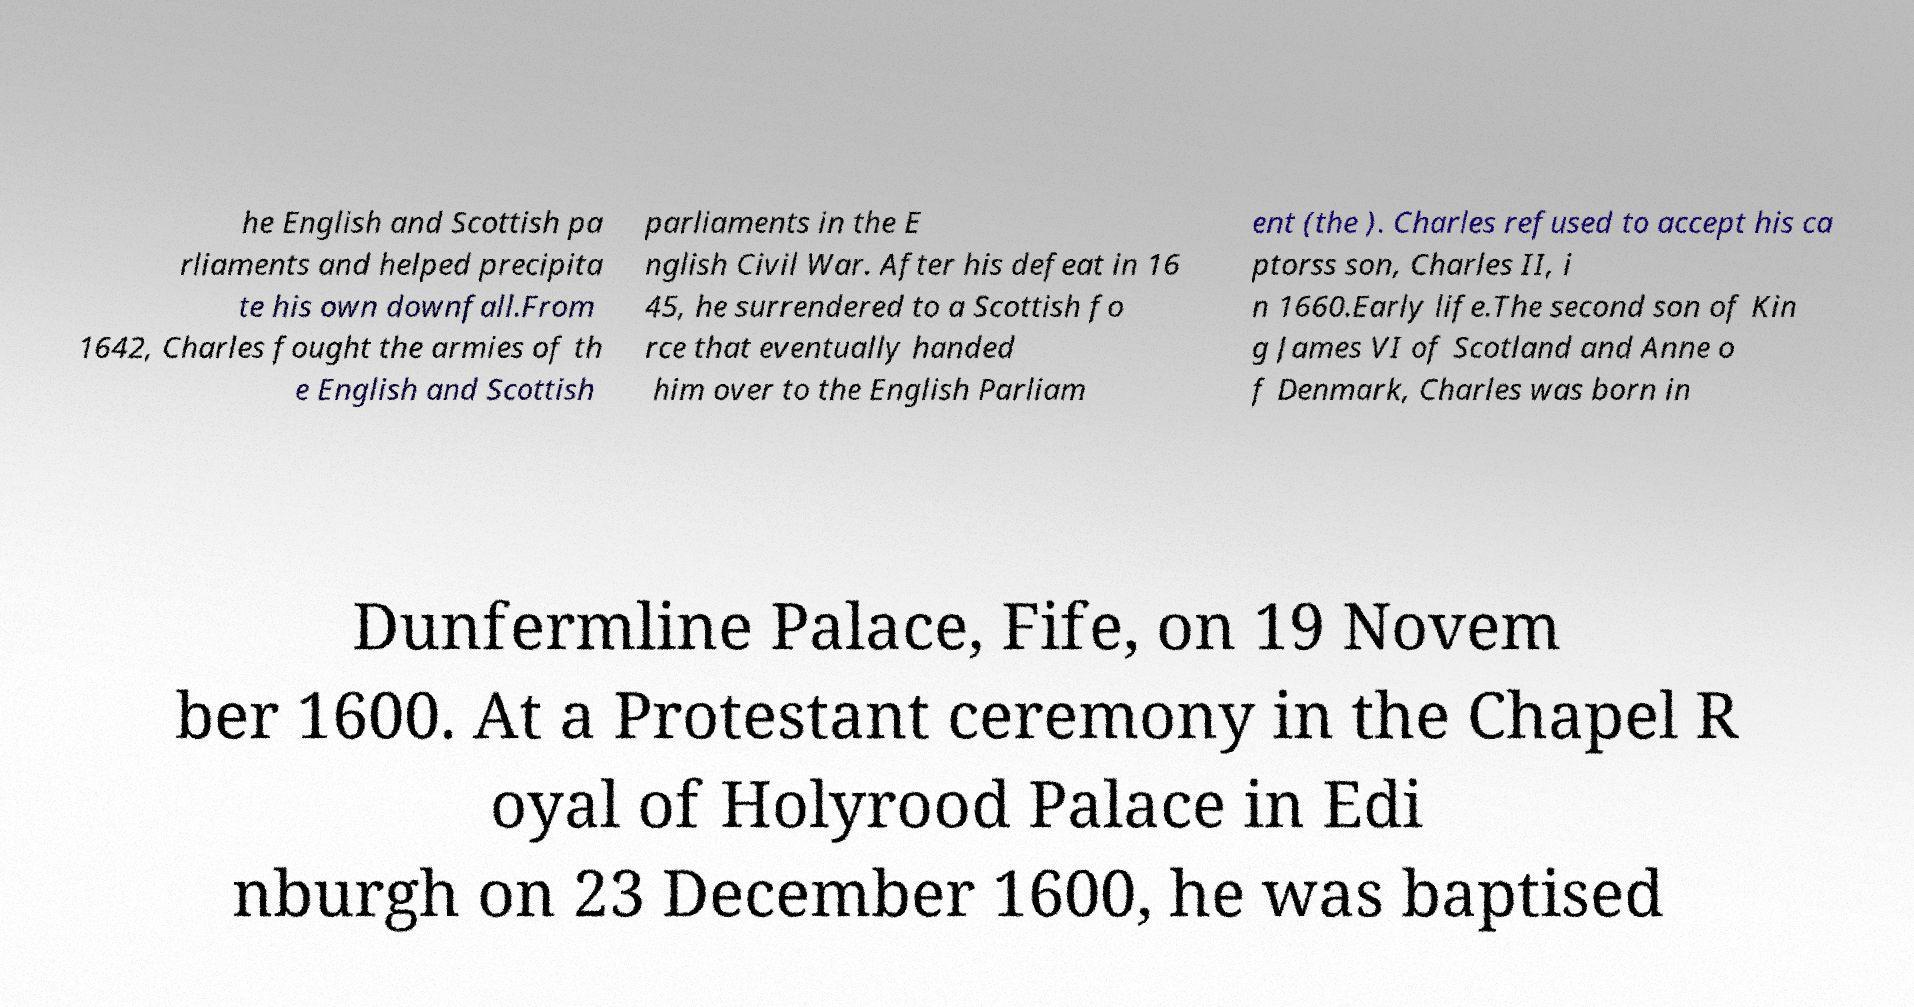Could you extract and type out the text from this image? he English and Scottish pa rliaments and helped precipita te his own downfall.From 1642, Charles fought the armies of th e English and Scottish parliaments in the E nglish Civil War. After his defeat in 16 45, he surrendered to a Scottish fo rce that eventually handed him over to the English Parliam ent (the ). Charles refused to accept his ca ptorss son, Charles II, i n 1660.Early life.The second son of Kin g James VI of Scotland and Anne o f Denmark, Charles was born in Dunfermline Palace, Fife, on 19 Novem ber 1600. At a Protestant ceremony in the Chapel R oyal of Holyrood Palace in Edi nburgh on 23 December 1600, he was baptised 